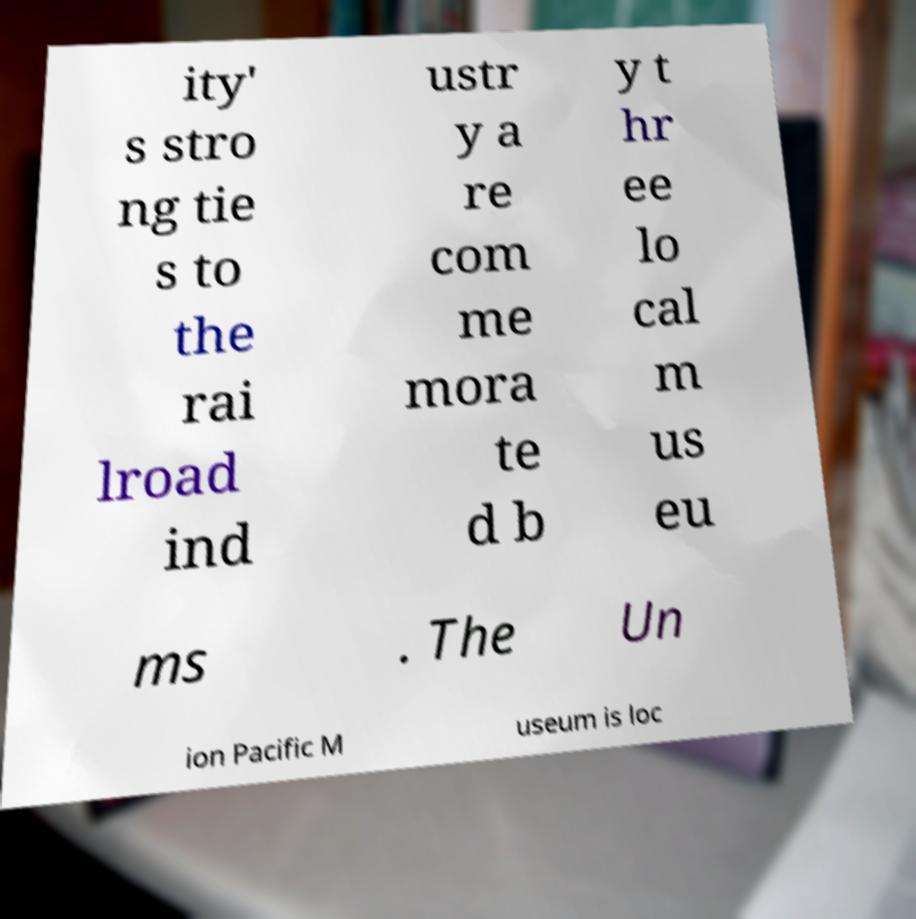What messages or text are displayed in this image? I need them in a readable, typed format. ity' s stro ng tie s to the rai lroad ind ustr y a re com me mora te d b y t hr ee lo cal m us eu ms . The Un ion Pacific M useum is loc 